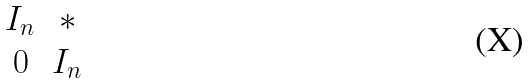<formula> <loc_0><loc_0><loc_500><loc_500>\begin{matrix} I _ { n } & * \\ 0 & I _ { n } \end{matrix}</formula> 